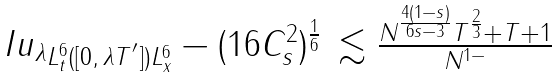Convert formula to latex. <formula><loc_0><loc_0><loc_500><loc_500>\begin{array} { l l } \| I u _ { \lambda } \| _ { L _ { t } ^ { 6 } ( [ 0 , \, \lambda T ^ { ^ { \prime } } ] ) L _ { x } ^ { 6 } } - ( 1 6 C _ { s } ^ { 2 } ) ^ { \frac { 1 } { 6 } } & \lesssim \frac { N ^ { \frac { 4 ( 1 - s ) } { 6 s - 3 } } T ^ { \frac { 2 } { 3 } } + T + 1 } { N ^ { 1 - } } \end{array}</formula> 